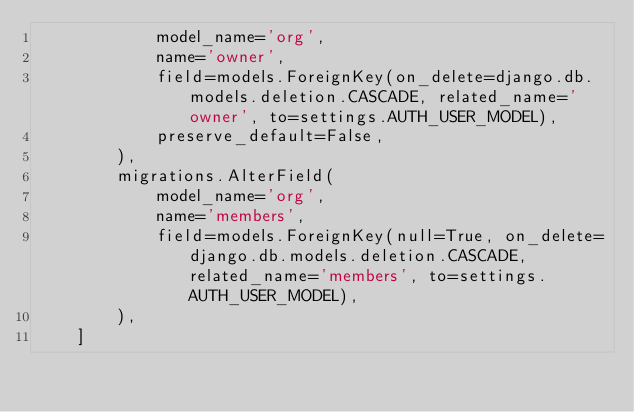Convert code to text. <code><loc_0><loc_0><loc_500><loc_500><_Python_>            model_name='org',
            name='owner',
            field=models.ForeignKey(on_delete=django.db.models.deletion.CASCADE, related_name='owner', to=settings.AUTH_USER_MODEL),
            preserve_default=False,
        ),
        migrations.AlterField(
            model_name='org',
            name='members',
            field=models.ForeignKey(null=True, on_delete=django.db.models.deletion.CASCADE, related_name='members', to=settings.AUTH_USER_MODEL),
        ),
    ]
</code> 